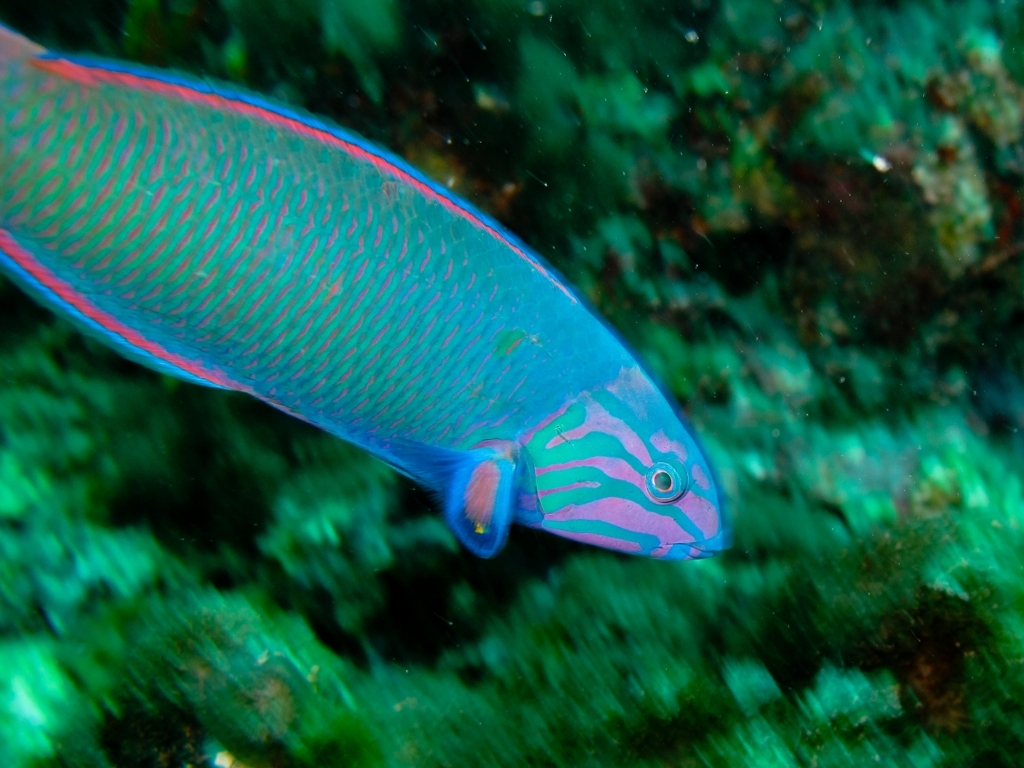Can you describe the habitat in which this fish is found? The fish is swimming in a marine environment, likely a coral reef given the rock formations and greenish algae seen in the background. Coral reefs are diverse underwater ecosystems held together by calcium carbonate structures secreted by corals. 